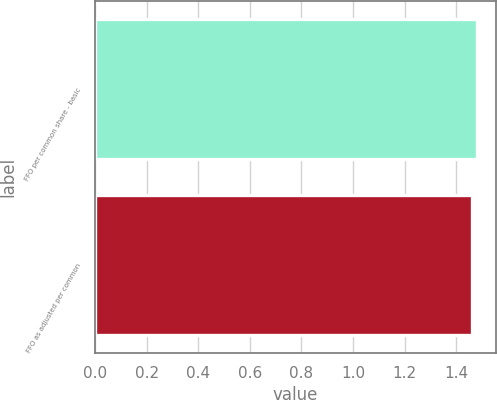Convert chart to OTSL. <chart><loc_0><loc_0><loc_500><loc_500><bar_chart><fcel>FFO per common share - basic<fcel>FFO as adjusted per common<nl><fcel>1.48<fcel>1.46<nl></chart> 